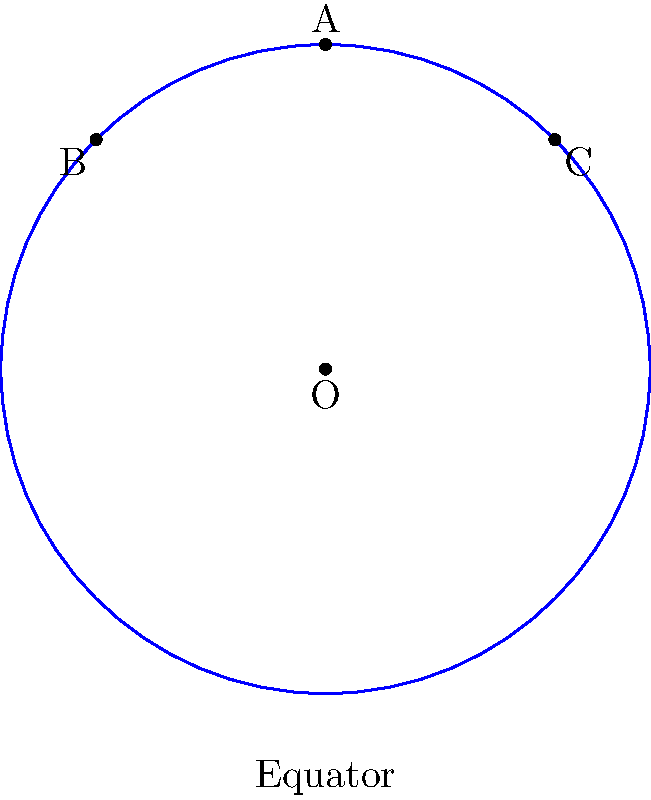In the context of non-Euclidean geometry applied to orthopedic imaging, consider a spherical model of the Earth with radius $R$. Two "parallel" lines are drawn from point A at the North Pole, forming great circles AB and AC that intersect the equator at points B and C, respectively. If the angle BOC at the center of the Earth is $\frac{\pi}{2}$ radians, what is the sum of the interior angles of triangle ABC? Let's approach this step-by-step:

1) In spherical geometry, great circles play the role of "straight lines". The sides of triangle ABC are arcs of great circles.

2) In a sphere, the sum of the angles in a triangle is always greater than $\pi$ radians (180°). The excess over $\pi$ is proportional to the area of the triangle.

3) The angle at A is $\frac{\pi}{2}$ radians (90°), as it's the angle between two great circles that are "parallel" at the pole.

4) The angle BOC at the center is given as $\frac{\pi}{2}$ radians. In a sphere, the angle between two great circles at their intersection point is equal to the angle between the planes containing these great circles. Therefore, the angle at B (and at C) in the spherical triangle is also $\frac{\pi}{2}$ radians.

5) Thus, we have a triangle where all three angles are $\frac{\pi}{2}$ radians (90°).

6) The sum of the angles is therefore:

   $\frac{\pi}{2} + \frac{\pi}{2} + \frac{\pi}{2} = \frac{3\pi}{2}$ radians, or 270°

This result demonstrates how the curvature of space in spherical geometry leads to the sum of angles in a triangle exceeding 180°, which is a key difference from Euclidean geometry.
Answer: $\frac{3\pi}{2}$ radians or 270° 